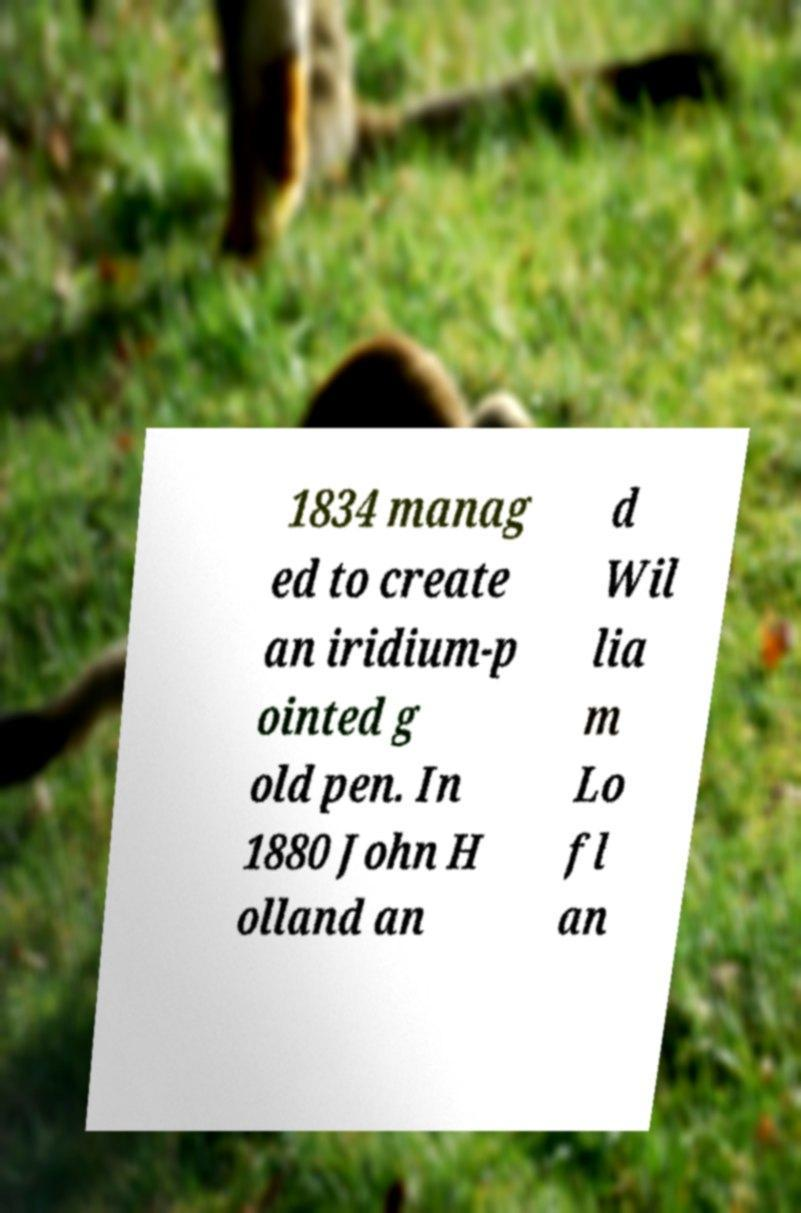I need the written content from this picture converted into text. Can you do that? 1834 manag ed to create an iridium-p ointed g old pen. In 1880 John H olland an d Wil lia m Lo fl an 